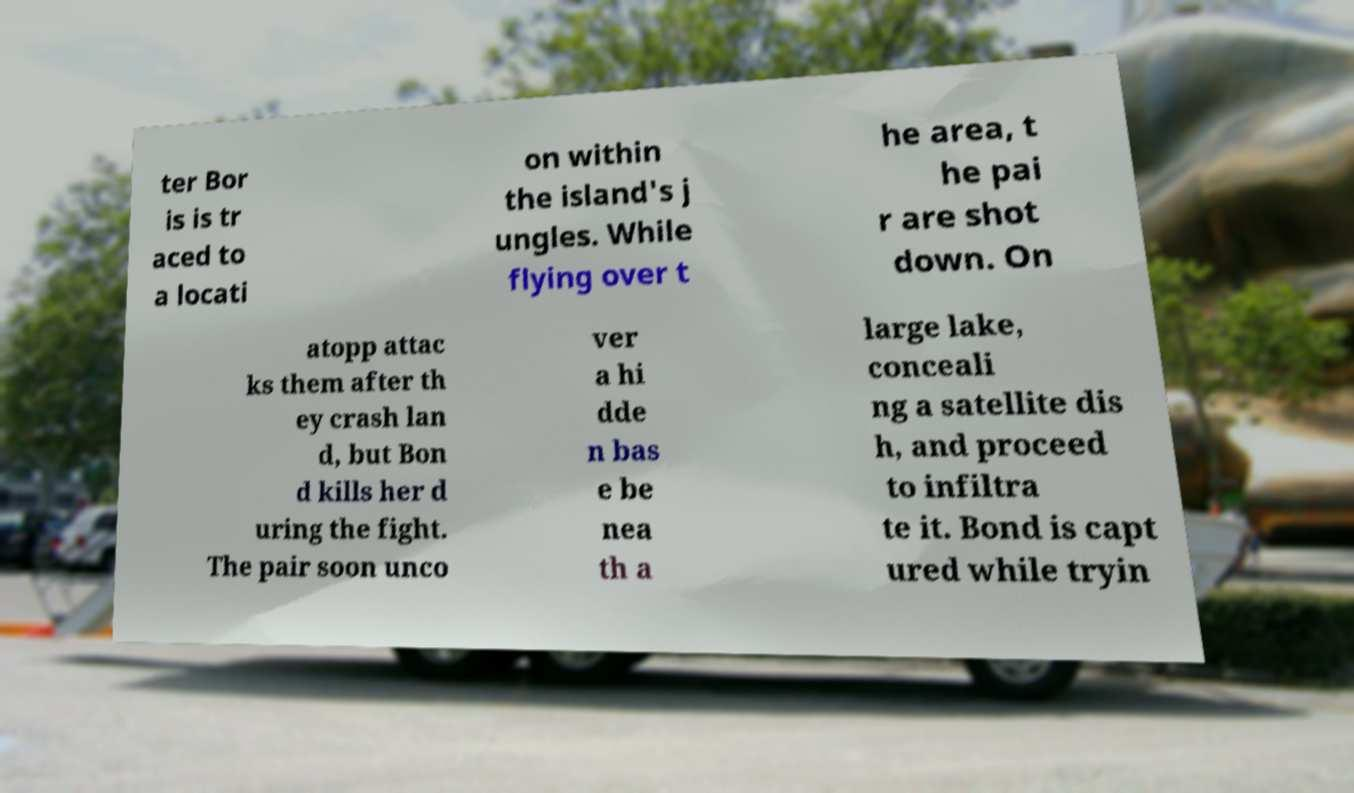Can you read and provide the text displayed in the image?This photo seems to have some interesting text. Can you extract and type it out for me? ter Bor is is tr aced to a locati on within the island's j ungles. While flying over t he area, t he pai r are shot down. On atopp attac ks them after th ey crash lan d, but Bon d kills her d uring the fight. The pair soon unco ver a hi dde n bas e be nea th a large lake, conceali ng a satellite dis h, and proceed to infiltra te it. Bond is capt ured while tryin 